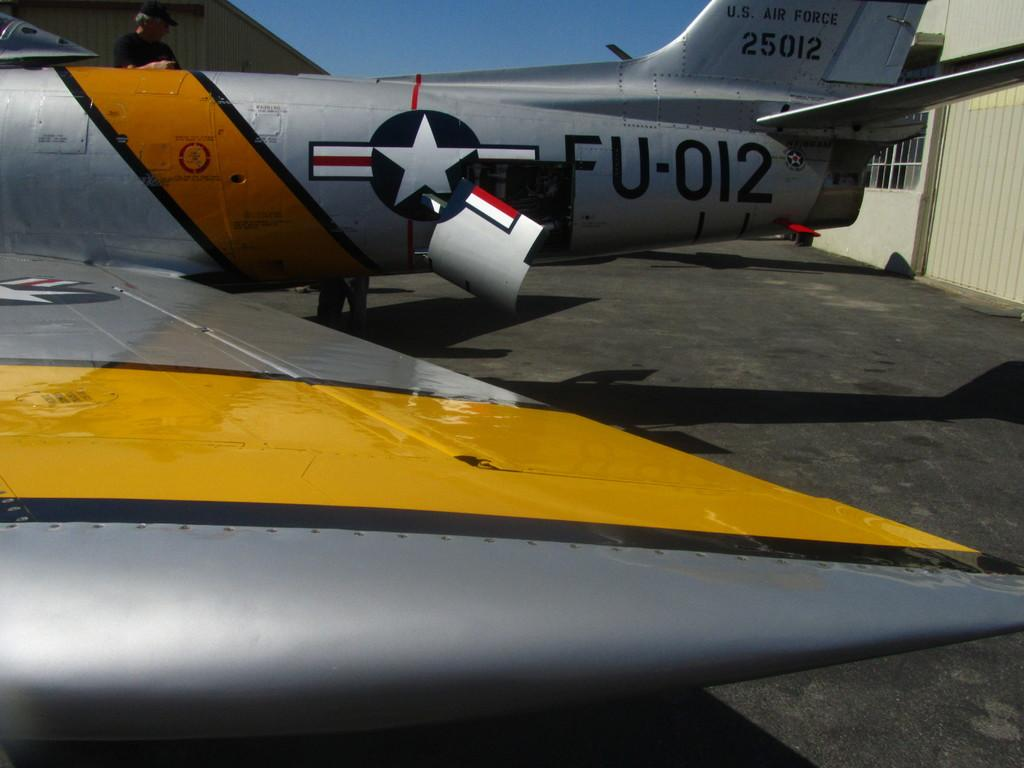What is the main subject in the foreground of the image? There is a vehicle part in the foreground of the image. What can be seen at the top of the image? The sky is visible at the top of the image. What is the flight with text and a symbol in the image? It is a flight, which typically refers to an airplane or aircraft, with text and a symbol. Can you describe the person on the flight? A person is present on the flight, but their appearance or actions are not specified in the image. What is located on the right side of the image? There is a window on the right side of the image, and a wall is associated with it. What type of crate is being used to hold the person's haircut in the image? There is no crate or haircut present in the image. 